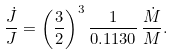<formula> <loc_0><loc_0><loc_500><loc_500>\frac { \dot { J } } { J } = \left ( \frac { 3 } { 2 } \right ) ^ { 3 } \frac { 1 } { 0 . 1 1 3 0 } \, \frac { \dot { M } } { M } .</formula> 